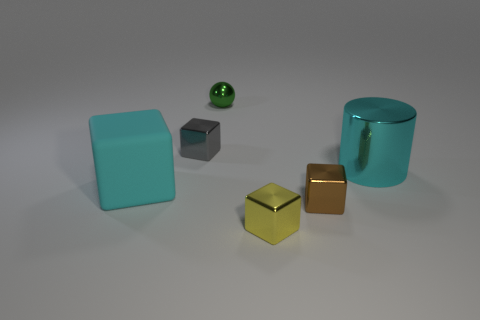What number of red things are big shiny objects or tiny rubber cubes?
Your response must be concise. 0. There is a metallic cube behind the large cyan metal cylinder; is it the same color as the metallic object that is on the right side of the brown metallic block?
Your answer should be very brief. No. The big thing behind the big cyan thing to the left of the tiny metallic cube that is behind the big cyan block is what color?
Provide a succinct answer. Cyan. Is there a tiny gray block that is right of the big thing that is behind the rubber thing?
Your answer should be compact. No. Does the small object that is in front of the tiny brown metallic thing have the same shape as the small gray object?
Provide a succinct answer. Yes. Are there any other things that have the same shape as the gray object?
Ensure brevity in your answer.  Yes. How many cubes are either small gray objects or large matte things?
Your response must be concise. 2. What number of matte objects are there?
Offer a very short reply. 1. There is a metal block to the left of the object that is in front of the tiny brown metal object; how big is it?
Keep it short and to the point. Small. What number of other objects are there of the same size as the gray shiny cube?
Provide a short and direct response. 3. 